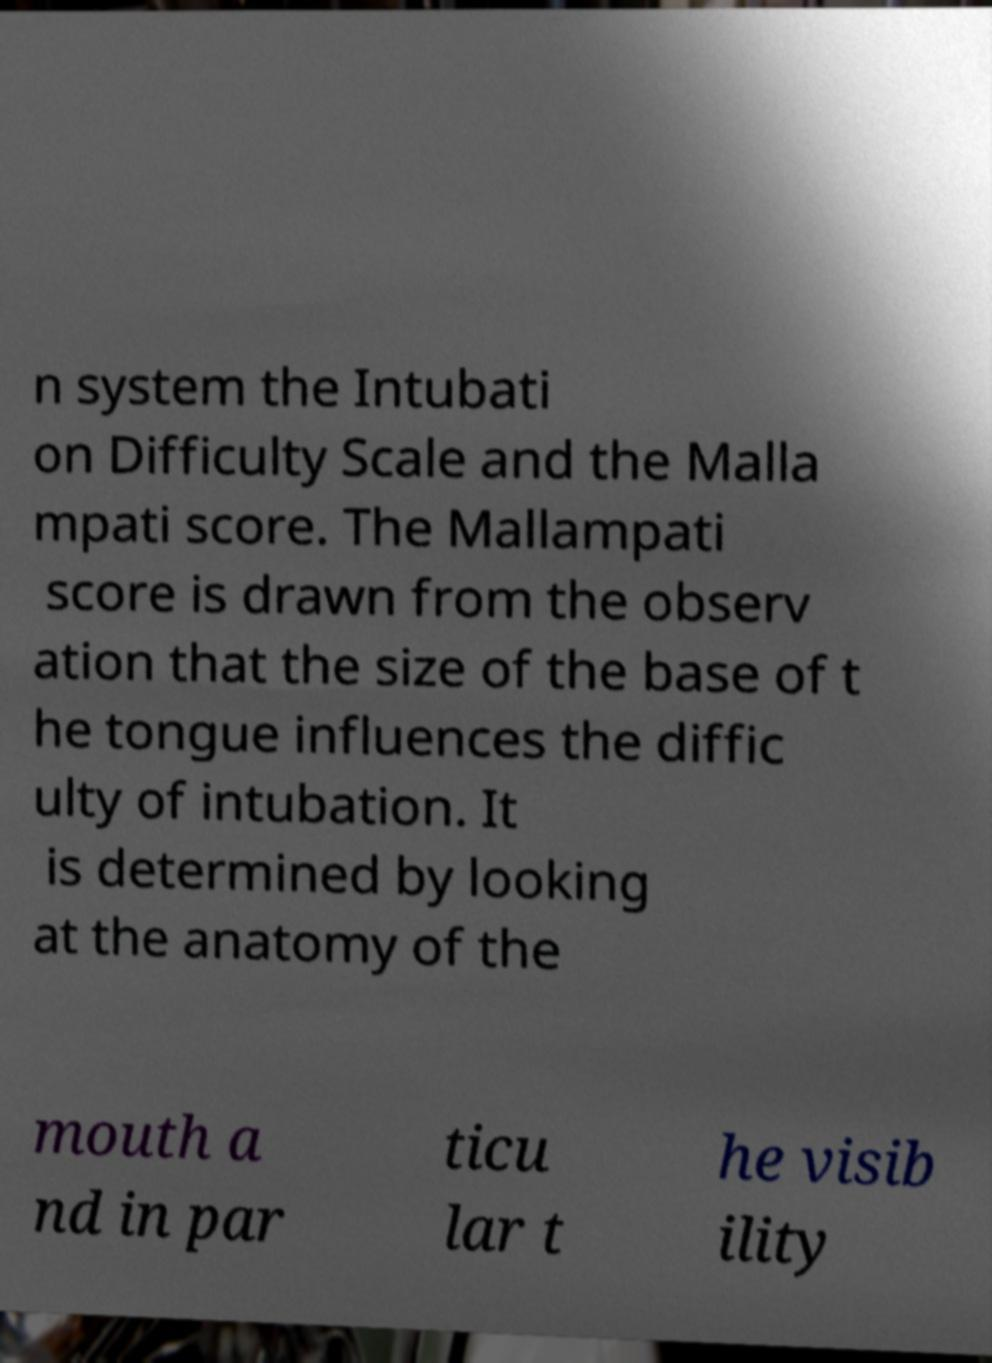I need the written content from this picture converted into text. Can you do that? n system the Intubati on Difficulty Scale and the Malla mpati score. The Mallampati score is drawn from the observ ation that the size of the base of t he tongue influences the diffic ulty of intubation. It is determined by looking at the anatomy of the mouth a nd in par ticu lar t he visib ility 